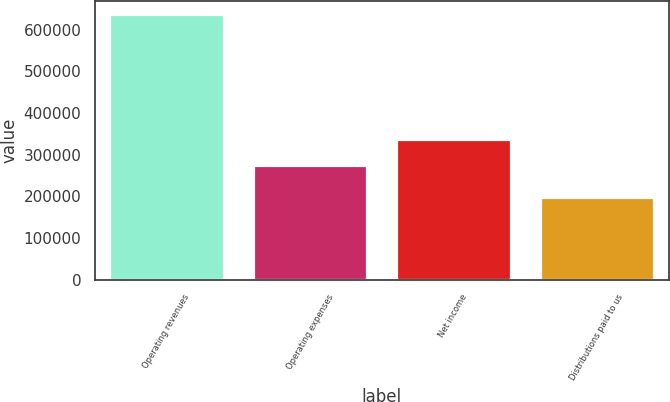Convert chart. <chart><loc_0><loc_0><loc_500><loc_500><bar_chart><fcel>Operating revenues<fcel>Operating expenses<fcel>Net income<fcel>Distributions paid to us<nl><fcel>637762<fcel>276373<fcel>337694<fcel>197285<nl></chart> 